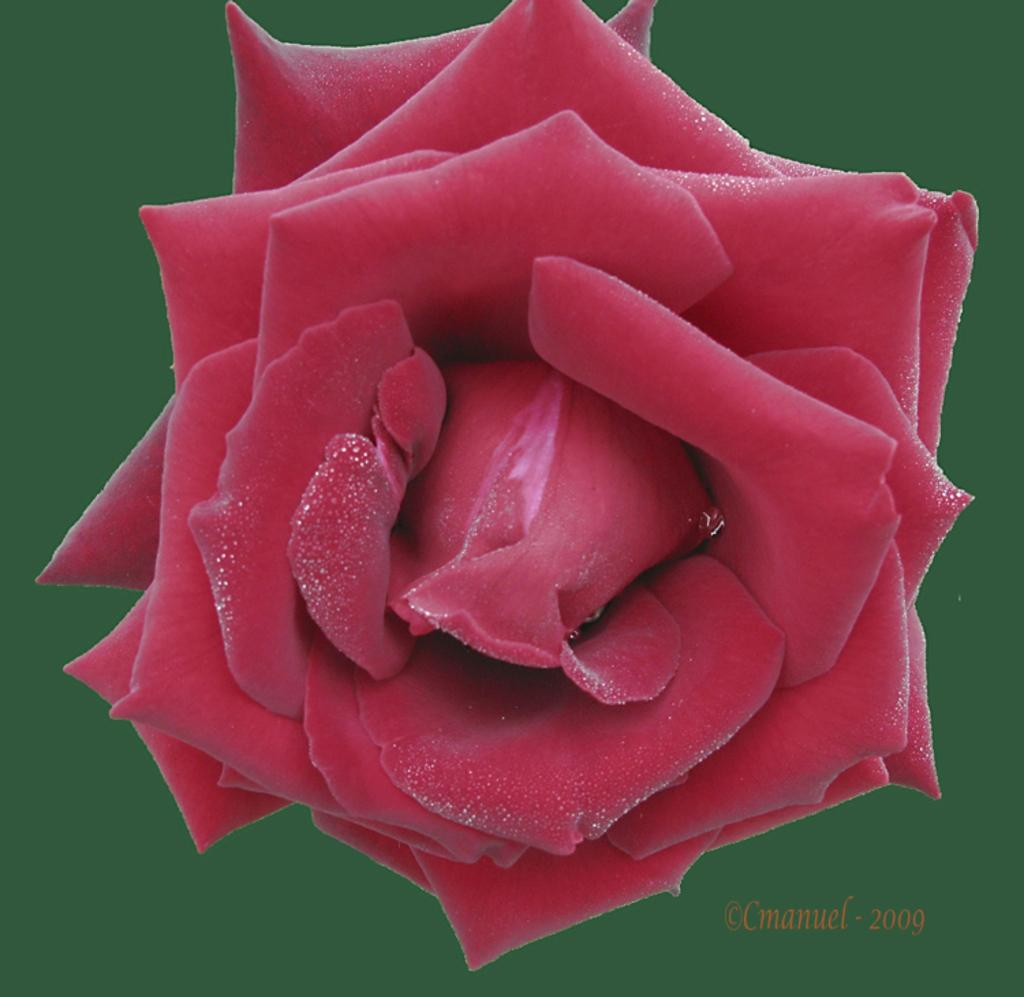What type of flower is in the image? There is a beautiful red rose in the image. What else can be seen in the image besides the red rose? There is a water marker in the image. How many geese are flying over the red rose in the image? There are no geese present in the image; it only features a red rose and a water marker. 